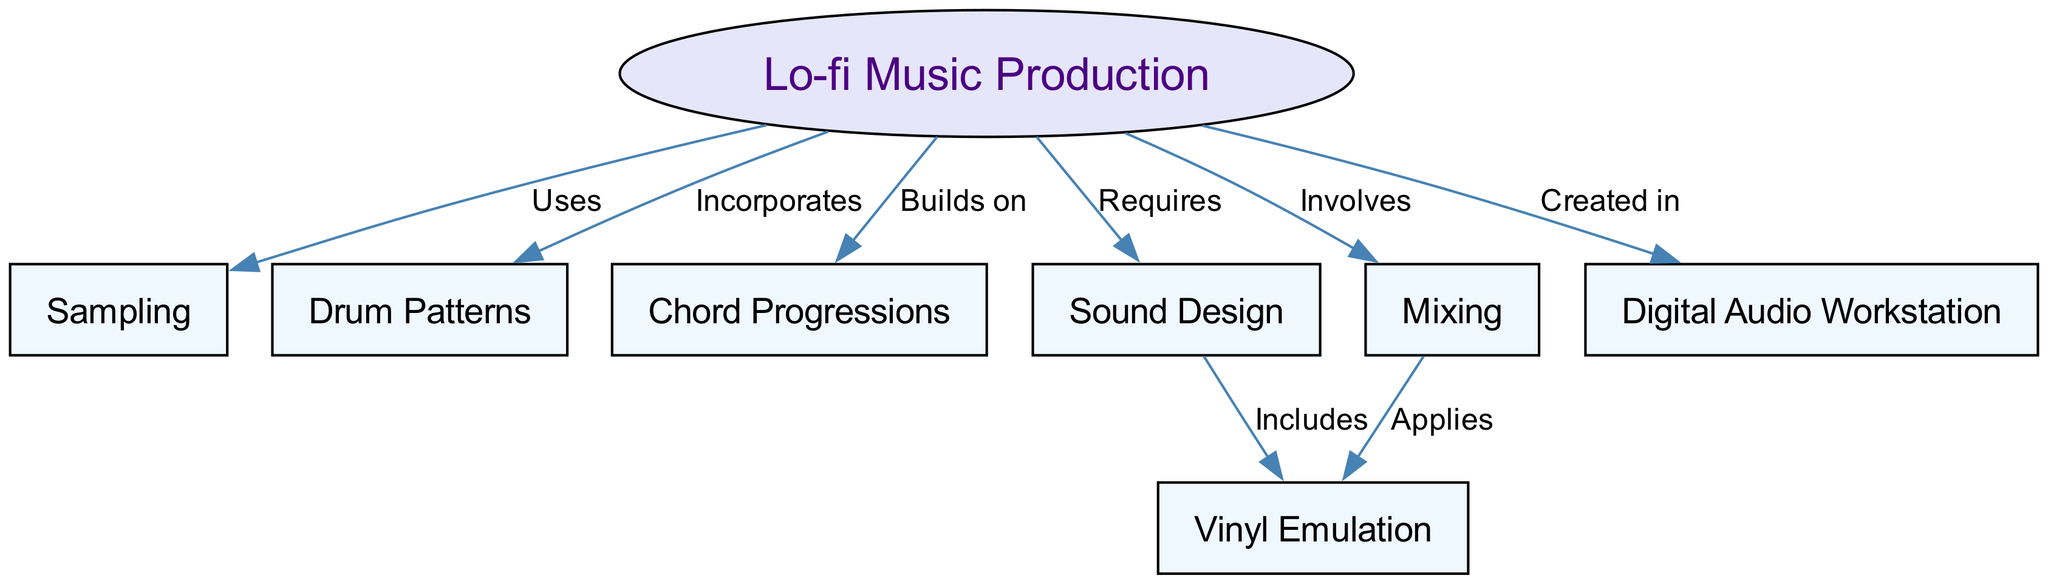What is the central concept of the diagram? The diagram focuses on "Lo-fi Music Production" as the central concept, indicating it is the main topic covered in the map.
Answer: Lo-fi Music Production How many nodes are present in the diagram? By counting the distinct elements represented within the diagram, there are a total of 7 nodes.
Answer: 7 Which node is connected to "Sound Design"? "Vinyl Emulation" is connected to "Sound Design" indicating that vinyl emulation is a component included within sound design processes.
Answer: Vinyl Emulation What type of relationship connects "Lo-fi Music Production" and "Drum Patterns"? The relationship is labeled "Incorporates," which shows that drum patterns are a key part of lo-fi music production.
Answer: Incorporates What does "Mixing" apply to within the context of the diagram? "Mixing" applies to "Vinyl Emulation," indicating that the mixing process in lo-fi production often utilizes techniques that emulate the sound of vinyl records.
Answer: Vinyl Emulation Which node represents the software aspect of production? The node "Digital Audio Workstation" represents the software aspect, where lo-fi music is created and produced digitally.
Answer: Digital Audio Workstation Describe the connection between "Sound Design" and "Vinyl Emulation." The connection shows that vinyl emulation is included within the broader scope of sound design, indicating it's part of creating the desired sound characteristics.
Answer: Includes What is one element that "Lo-fi Music Production" requires? One element that "Lo-fi Music Production" requires is "Sound Design," which is essential for creating the unique textures in lo-fi tracks.
Answer: Sound Design How does "Mixing" relate to "Lo-fi Music Production"? "Mixing" involves crucial processes in lo-fi music production, ensuring that various elements blend well together to create a cohesive track.
Answer: Involves 